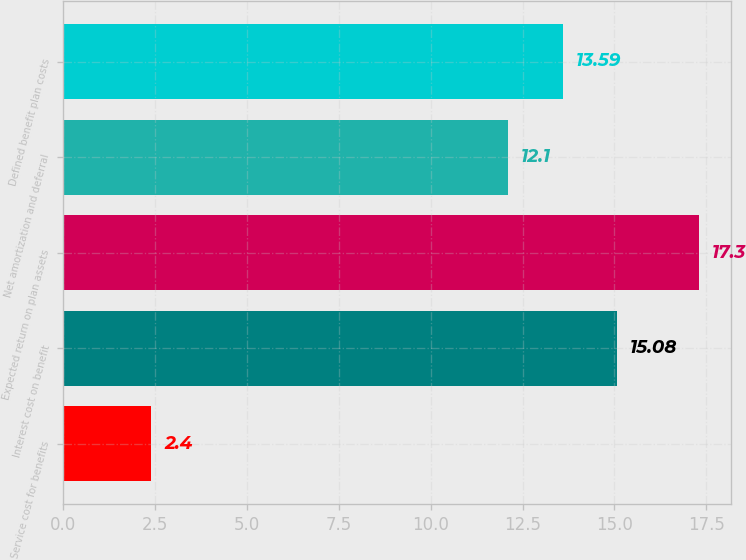Convert chart to OTSL. <chart><loc_0><loc_0><loc_500><loc_500><bar_chart><fcel>Service cost for benefits<fcel>Interest cost on benefit<fcel>Expected return on plan assets<fcel>Net amortization and deferral<fcel>Defined benefit plan costs<nl><fcel>2.4<fcel>15.08<fcel>17.3<fcel>12.1<fcel>13.59<nl></chart> 